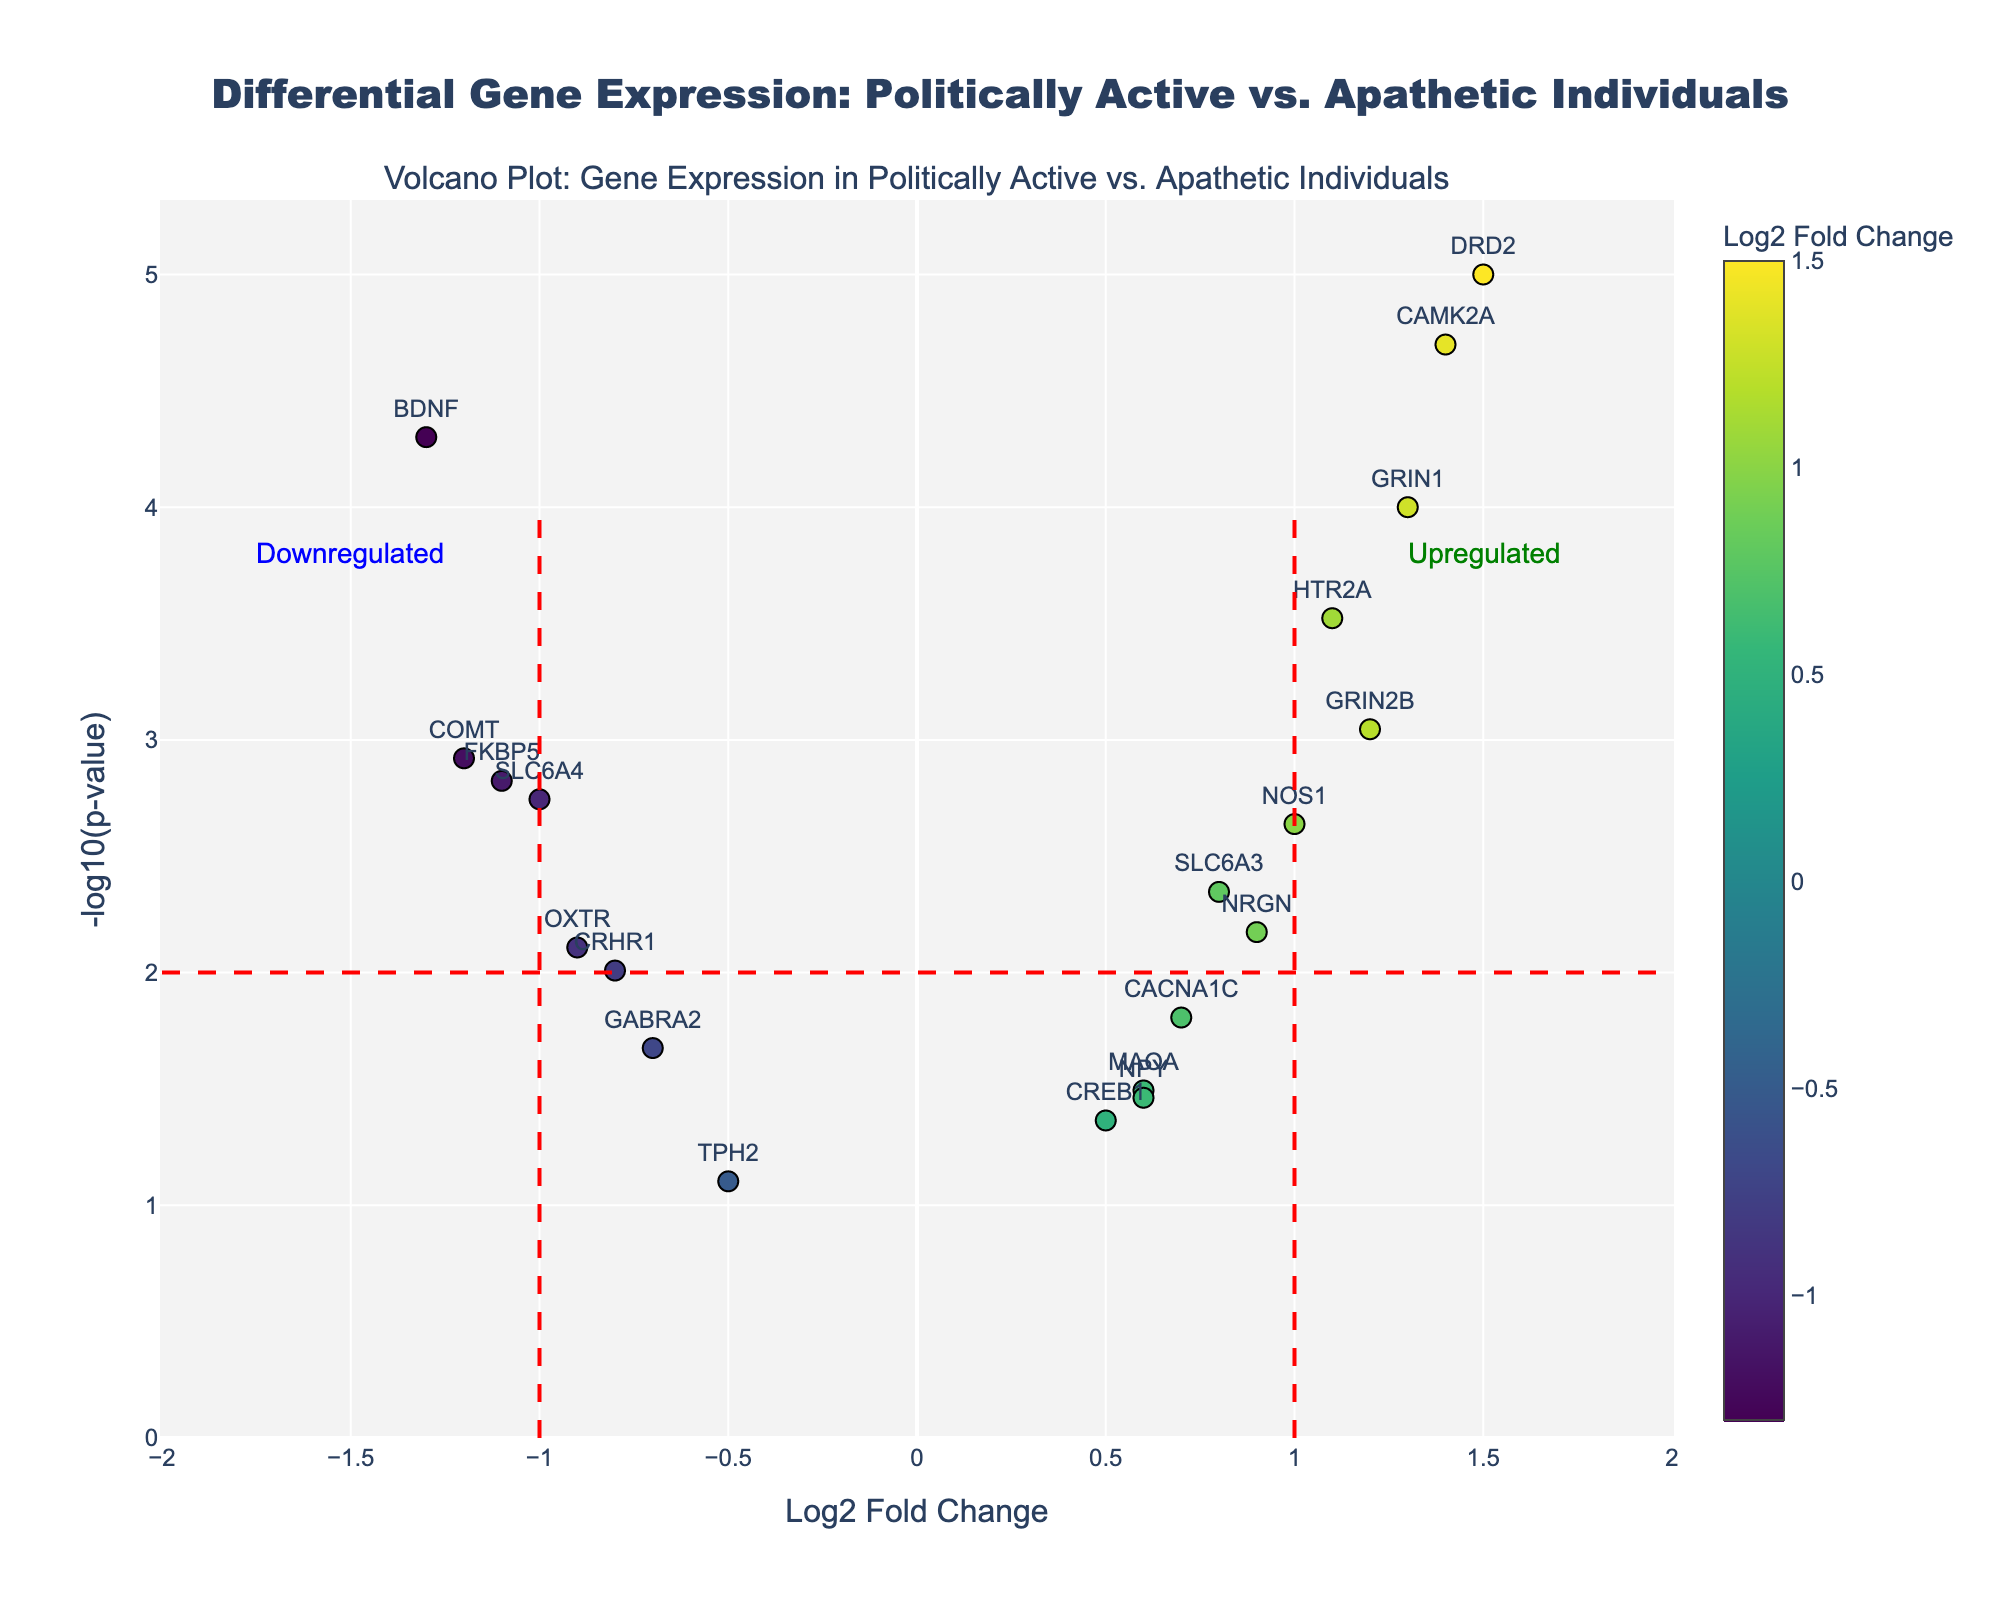What's the color scheme of the data points on the plot? There is a colorscale used for the data points, which ranges from yellow to dark purple. The color represents the Log2 Fold Change, with yellow indicating higher Log2 Fold Change values and dark purple indicating lower values.
Answer: From yellow to dark purple What is the title of the figure? The title is located at the top of the figure and reads: "Differential Gene Expression: Politically Active vs. Apathetic Individuals".
Answer: Differential Gene Expression: Politically Active vs. Apathetic Individuals How many genes have significant upregulation in politically active individuals? Upregulation is indicated by positive Log2 Fold Change values and -log10(p-value) above 2. By quick observation, the genes with such characteristics include DRD2, HTR2A, GRIN2B, CAMK2A, and GRIN1. There are 5 genes in total.
Answer: 5 Which gene has the largest Log2 Fold Change, and is it upregulated or downregulated? By looking at the x-axis for the largest absolute value, DRD2 has the largest positive Log2 Fold Change (1.5), indicating upregulation.
Answer: DRD2, upregulated Identify the gene with the smallest p-value and its corresponding Log2 Fold Change. The smallest p-value will correspond to the highest -log10(p-value). Checking the plot, DRD2 has the smallest p-value (0.00001), and its Log2 Fold Change is 1.5.
Answer: DRD2, 1.5 Which annotations indicate the regions for upregulated and downregulated genes? Upregulated genes are on the right side with positive Log2 Fold Change, marked by an annotation labeled "Upregulated." Downregulated genes are on the left side with negative Log2 Fold Change, marked by an annotation labeled "Downregulated".
Answer: Upregulated on right, Downregulated on left How many genes fall below the significance threshold of -log10(p-value) = 2? By examining the plot, count the number of points below the horizontal red threshold line corresponding to -log10(p-value) = 2. There are several points below this line, indicating their p-values are higher than 0.01.
Answer: 6 Which gene has a downregulation of Log2 Fold Change = -1.0, and what is its p-value? Checking the markers along the -1.0 Log2 Fold Change line and identifying the corresponding p-value, SLC6A4 is the gene with a Log2 Fold Change of -1.0 and its p-value is 0.0018.
Answer: SLC6A4, 0.0018 What is the range of -log10(p-value) values present in the plot? The highest value on the y-axis for -log10(p-value) appears to be around 5, and the lowest value is approximately 1. Therefore, the range is from 1 to 5.
Answer: 1 to 5 